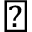Convert formula to latex. <formula><loc_0><loc_0><loc_500><loc_500>\check { m } a r k</formula> 